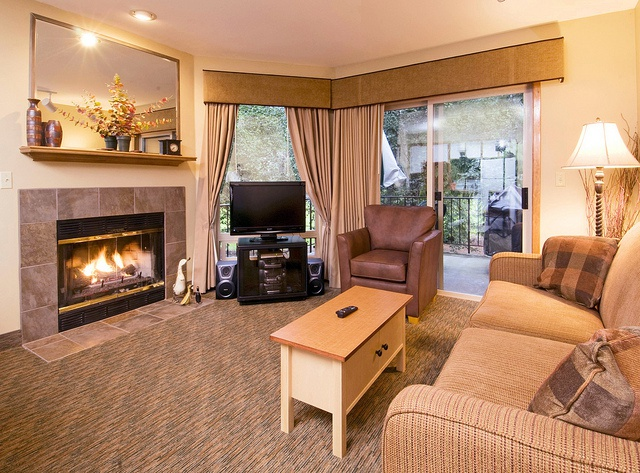Describe the objects in this image and their specific colors. I can see couch in tan and salmon tones, chair in tan, brown, and maroon tones, tv in tan, black, gray, and darkgray tones, potted plant in tan, red, and orange tones, and vase in tan, brown, lightpink, and maroon tones in this image. 